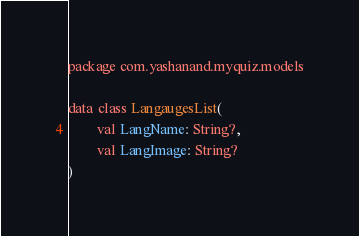<code> <loc_0><loc_0><loc_500><loc_500><_Kotlin_>package com.yashanand.myquiz.models

data class LangaugesList(
        val LangName: String?,
        val LangImage: String?
)
</code> 